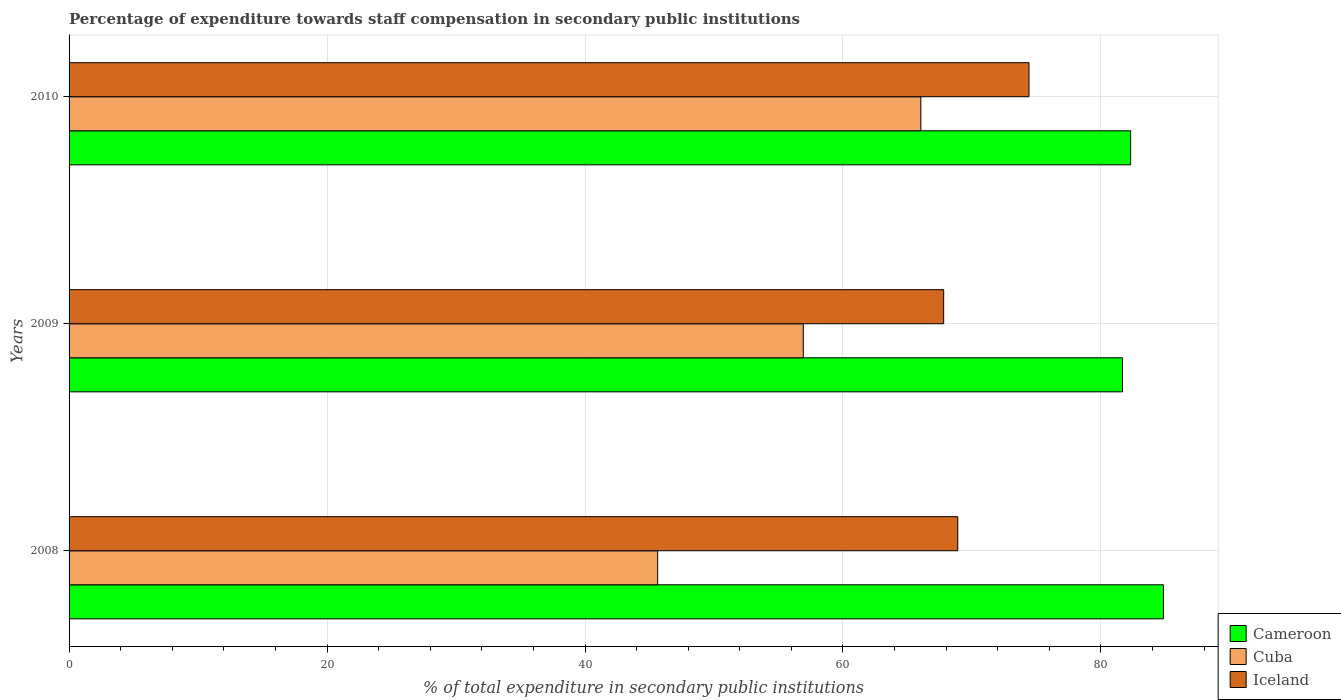How many different coloured bars are there?
Your response must be concise. 3. Are the number of bars per tick equal to the number of legend labels?
Provide a succinct answer. Yes. What is the label of the 1st group of bars from the top?
Make the answer very short. 2010. What is the percentage of expenditure towards staff compensation in Iceland in 2009?
Make the answer very short. 67.81. Across all years, what is the maximum percentage of expenditure towards staff compensation in Cameroon?
Give a very brief answer. 84.84. Across all years, what is the minimum percentage of expenditure towards staff compensation in Cuba?
Give a very brief answer. 45.63. What is the total percentage of expenditure towards staff compensation in Cuba in the graph?
Provide a short and direct response. 168.59. What is the difference between the percentage of expenditure towards staff compensation in Cameroon in 2009 and that in 2010?
Offer a very short reply. -0.63. What is the difference between the percentage of expenditure towards staff compensation in Iceland in 2010 and the percentage of expenditure towards staff compensation in Cuba in 2008?
Your answer should be compact. 28.79. What is the average percentage of expenditure towards staff compensation in Cameroon per year?
Provide a short and direct response. 82.94. In the year 2009, what is the difference between the percentage of expenditure towards staff compensation in Cameroon and percentage of expenditure towards staff compensation in Iceland?
Give a very brief answer. 13.86. What is the ratio of the percentage of expenditure towards staff compensation in Iceland in 2008 to that in 2009?
Ensure brevity in your answer.  1.02. What is the difference between the highest and the second highest percentage of expenditure towards staff compensation in Cuba?
Give a very brief answer. 9.11. What is the difference between the highest and the lowest percentage of expenditure towards staff compensation in Cuba?
Ensure brevity in your answer.  20.41. In how many years, is the percentage of expenditure towards staff compensation in Cameroon greater than the average percentage of expenditure towards staff compensation in Cameroon taken over all years?
Your answer should be compact. 1. Is the sum of the percentage of expenditure towards staff compensation in Cuba in 2008 and 2010 greater than the maximum percentage of expenditure towards staff compensation in Iceland across all years?
Offer a very short reply. Yes. What does the 3rd bar from the top in 2010 represents?
Offer a very short reply. Cameroon. What does the 1st bar from the bottom in 2010 represents?
Give a very brief answer. Cameroon. How many bars are there?
Offer a very short reply. 9. Are all the bars in the graph horizontal?
Keep it short and to the point. Yes. How many years are there in the graph?
Your answer should be very brief. 3. Does the graph contain grids?
Provide a succinct answer. Yes. Where does the legend appear in the graph?
Offer a very short reply. Bottom right. What is the title of the graph?
Ensure brevity in your answer.  Percentage of expenditure towards staff compensation in secondary public institutions. Does "Cabo Verde" appear as one of the legend labels in the graph?
Keep it short and to the point. No. What is the label or title of the X-axis?
Ensure brevity in your answer.  % of total expenditure in secondary public institutions. What is the label or title of the Y-axis?
Give a very brief answer. Years. What is the % of total expenditure in secondary public institutions of Cameroon in 2008?
Provide a succinct answer. 84.84. What is the % of total expenditure in secondary public institutions in Cuba in 2008?
Your answer should be compact. 45.63. What is the % of total expenditure in secondary public institutions of Iceland in 2008?
Provide a succinct answer. 68.9. What is the % of total expenditure in secondary public institutions in Cameroon in 2009?
Provide a short and direct response. 81.67. What is the % of total expenditure in secondary public institutions of Cuba in 2009?
Offer a very short reply. 56.92. What is the % of total expenditure in secondary public institutions of Iceland in 2009?
Your response must be concise. 67.81. What is the % of total expenditure in secondary public institutions of Cameroon in 2010?
Provide a succinct answer. 82.3. What is the % of total expenditure in secondary public institutions in Cuba in 2010?
Give a very brief answer. 66.04. What is the % of total expenditure in secondary public institutions in Iceland in 2010?
Your answer should be compact. 74.42. Across all years, what is the maximum % of total expenditure in secondary public institutions in Cameroon?
Your answer should be very brief. 84.84. Across all years, what is the maximum % of total expenditure in secondary public institutions of Cuba?
Your answer should be very brief. 66.04. Across all years, what is the maximum % of total expenditure in secondary public institutions in Iceland?
Provide a short and direct response. 74.42. Across all years, what is the minimum % of total expenditure in secondary public institutions of Cameroon?
Your answer should be very brief. 81.67. Across all years, what is the minimum % of total expenditure in secondary public institutions of Cuba?
Your response must be concise. 45.63. Across all years, what is the minimum % of total expenditure in secondary public institutions of Iceland?
Make the answer very short. 67.81. What is the total % of total expenditure in secondary public institutions in Cameroon in the graph?
Ensure brevity in your answer.  248.82. What is the total % of total expenditure in secondary public institutions in Cuba in the graph?
Provide a short and direct response. 168.59. What is the total % of total expenditure in secondary public institutions of Iceland in the graph?
Keep it short and to the point. 211.13. What is the difference between the % of total expenditure in secondary public institutions in Cameroon in 2008 and that in 2009?
Provide a succinct answer. 3.18. What is the difference between the % of total expenditure in secondary public institutions in Cuba in 2008 and that in 2009?
Give a very brief answer. -11.29. What is the difference between the % of total expenditure in secondary public institutions of Iceland in 2008 and that in 2009?
Offer a terse response. 1.09. What is the difference between the % of total expenditure in secondary public institutions in Cameroon in 2008 and that in 2010?
Provide a short and direct response. 2.54. What is the difference between the % of total expenditure in secondary public institutions in Cuba in 2008 and that in 2010?
Give a very brief answer. -20.41. What is the difference between the % of total expenditure in secondary public institutions of Iceland in 2008 and that in 2010?
Offer a terse response. -5.52. What is the difference between the % of total expenditure in secondary public institutions in Cameroon in 2009 and that in 2010?
Your answer should be compact. -0.63. What is the difference between the % of total expenditure in secondary public institutions of Cuba in 2009 and that in 2010?
Offer a terse response. -9.11. What is the difference between the % of total expenditure in secondary public institutions in Iceland in 2009 and that in 2010?
Ensure brevity in your answer.  -6.62. What is the difference between the % of total expenditure in secondary public institutions in Cameroon in 2008 and the % of total expenditure in secondary public institutions in Cuba in 2009?
Offer a very short reply. 27.92. What is the difference between the % of total expenditure in secondary public institutions of Cameroon in 2008 and the % of total expenditure in secondary public institutions of Iceland in 2009?
Keep it short and to the point. 17.04. What is the difference between the % of total expenditure in secondary public institutions in Cuba in 2008 and the % of total expenditure in secondary public institutions in Iceland in 2009?
Give a very brief answer. -22.18. What is the difference between the % of total expenditure in secondary public institutions of Cameroon in 2008 and the % of total expenditure in secondary public institutions of Cuba in 2010?
Give a very brief answer. 18.81. What is the difference between the % of total expenditure in secondary public institutions in Cameroon in 2008 and the % of total expenditure in secondary public institutions in Iceland in 2010?
Your answer should be compact. 10.42. What is the difference between the % of total expenditure in secondary public institutions in Cuba in 2008 and the % of total expenditure in secondary public institutions in Iceland in 2010?
Provide a succinct answer. -28.79. What is the difference between the % of total expenditure in secondary public institutions of Cameroon in 2009 and the % of total expenditure in secondary public institutions of Cuba in 2010?
Provide a short and direct response. 15.63. What is the difference between the % of total expenditure in secondary public institutions of Cameroon in 2009 and the % of total expenditure in secondary public institutions of Iceland in 2010?
Provide a short and direct response. 7.25. What is the difference between the % of total expenditure in secondary public institutions in Cuba in 2009 and the % of total expenditure in secondary public institutions in Iceland in 2010?
Make the answer very short. -17.5. What is the average % of total expenditure in secondary public institutions of Cameroon per year?
Provide a succinct answer. 82.94. What is the average % of total expenditure in secondary public institutions in Cuba per year?
Provide a short and direct response. 56.2. What is the average % of total expenditure in secondary public institutions in Iceland per year?
Make the answer very short. 70.38. In the year 2008, what is the difference between the % of total expenditure in secondary public institutions of Cameroon and % of total expenditure in secondary public institutions of Cuba?
Provide a short and direct response. 39.21. In the year 2008, what is the difference between the % of total expenditure in secondary public institutions of Cameroon and % of total expenditure in secondary public institutions of Iceland?
Make the answer very short. 15.95. In the year 2008, what is the difference between the % of total expenditure in secondary public institutions of Cuba and % of total expenditure in secondary public institutions of Iceland?
Your response must be concise. -23.27. In the year 2009, what is the difference between the % of total expenditure in secondary public institutions in Cameroon and % of total expenditure in secondary public institutions in Cuba?
Keep it short and to the point. 24.74. In the year 2009, what is the difference between the % of total expenditure in secondary public institutions in Cameroon and % of total expenditure in secondary public institutions in Iceland?
Offer a terse response. 13.86. In the year 2009, what is the difference between the % of total expenditure in secondary public institutions in Cuba and % of total expenditure in secondary public institutions in Iceland?
Give a very brief answer. -10.88. In the year 2010, what is the difference between the % of total expenditure in secondary public institutions of Cameroon and % of total expenditure in secondary public institutions of Cuba?
Your answer should be very brief. 16.27. In the year 2010, what is the difference between the % of total expenditure in secondary public institutions of Cameroon and % of total expenditure in secondary public institutions of Iceland?
Your response must be concise. 7.88. In the year 2010, what is the difference between the % of total expenditure in secondary public institutions in Cuba and % of total expenditure in secondary public institutions in Iceland?
Ensure brevity in your answer.  -8.39. What is the ratio of the % of total expenditure in secondary public institutions of Cameroon in 2008 to that in 2009?
Provide a short and direct response. 1.04. What is the ratio of the % of total expenditure in secondary public institutions of Cuba in 2008 to that in 2009?
Provide a short and direct response. 0.8. What is the ratio of the % of total expenditure in secondary public institutions of Iceland in 2008 to that in 2009?
Offer a very short reply. 1.02. What is the ratio of the % of total expenditure in secondary public institutions in Cameroon in 2008 to that in 2010?
Provide a succinct answer. 1.03. What is the ratio of the % of total expenditure in secondary public institutions of Cuba in 2008 to that in 2010?
Offer a terse response. 0.69. What is the ratio of the % of total expenditure in secondary public institutions in Iceland in 2008 to that in 2010?
Provide a succinct answer. 0.93. What is the ratio of the % of total expenditure in secondary public institutions of Cameroon in 2009 to that in 2010?
Your response must be concise. 0.99. What is the ratio of the % of total expenditure in secondary public institutions in Cuba in 2009 to that in 2010?
Ensure brevity in your answer.  0.86. What is the ratio of the % of total expenditure in secondary public institutions in Iceland in 2009 to that in 2010?
Your answer should be compact. 0.91. What is the difference between the highest and the second highest % of total expenditure in secondary public institutions in Cameroon?
Offer a very short reply. 2.54. What is the difference between the highest and the second highest % of total expenditure in secondary public institutions in Cuba?
Make the answer very short. 9.11. What is the difference between the highest and the second highest % of total expenditure in secondary public institutions in Iceland?
Your answer should be compact. 5.52. What is the difference between the highest and the lowest % of total expenditure in secondary public institutions in Cameroon?
Make the answer very short. 3.18. What is the difference between the highest and the lowest % of total expenditure in secondary public institutions of Cuba?
Offer a terse response. 20.41. What is the difference between the highest and the lowest % of total expenditure in secondary public institutions of Iceland?
Your answer should be compact. 6.62. 